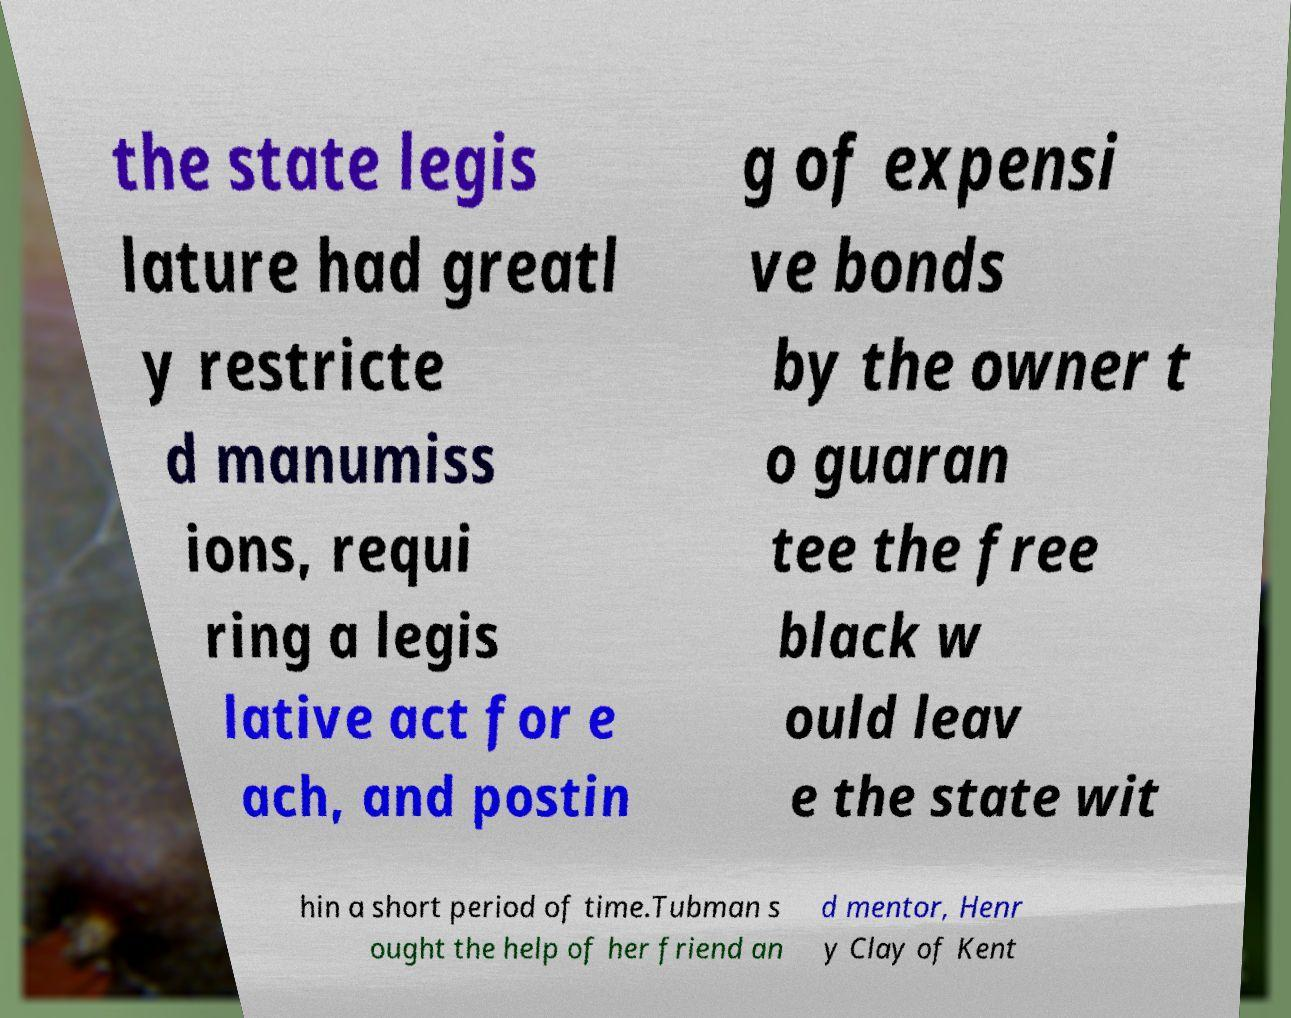Could you extract and type out the text from this image? the state legis lature had greatl y restricte d manumiss ions, requi ring a legis lative act for e ach, and postin g of expensi ve bonds by the owner t o guaran tee the free black w ould leav e the state wit hin a short period of time.Tubman s ought the help of her friend an d mentor, Henr y Clay of Kent 